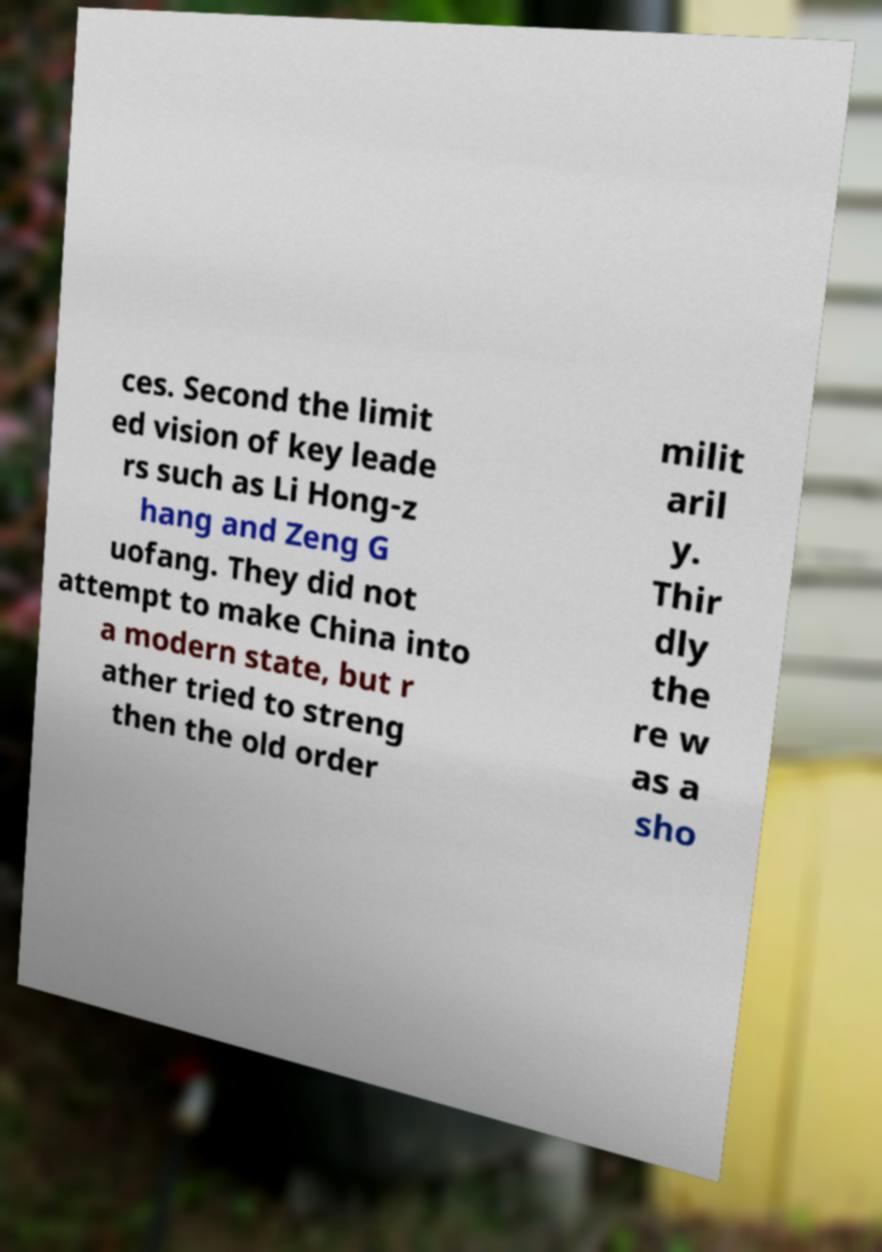For documentation purposes, I need the text within this image transcribed. Could you provide that? ces. Second the limit ed vision of key leade rs such as Li Hong-z hang and Zeng G uofang. They did not attempt to make China into a modern state, but r ather tried to streng then the old order milit aril y. Thir dly the re w as a sho 